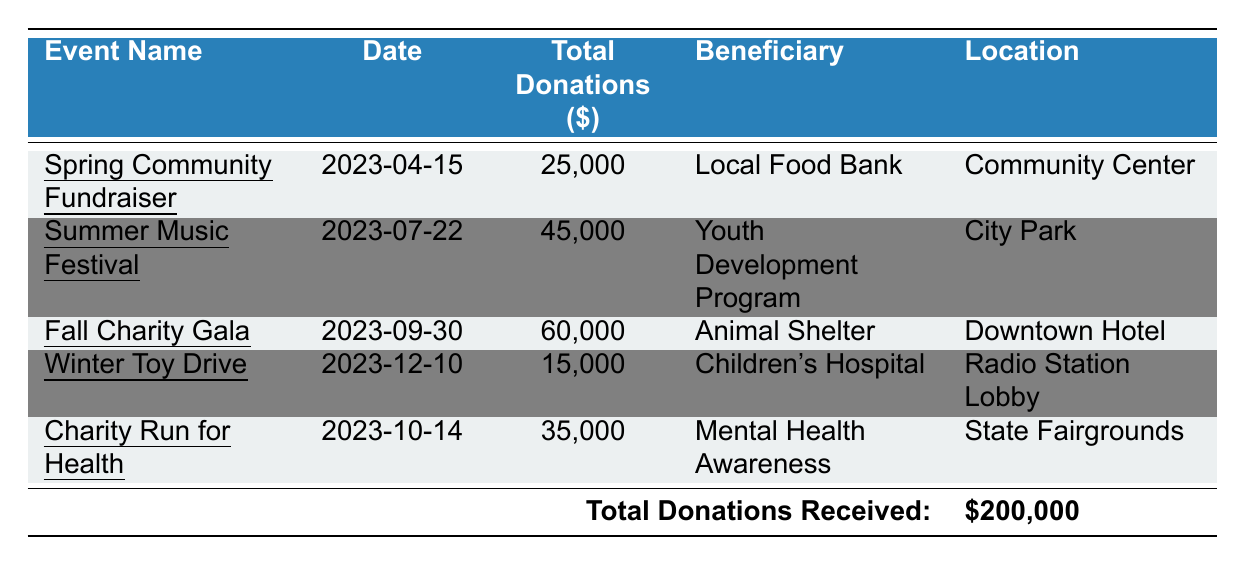What is the total amount of donations received from the Spring Community Fundraiser? The table shows that the total donations for the Spring Community Fundraiser is listed as 25,000.
Answer: 25,000 Which charity benefited from the Fall Charity Gala? According to the table, the beneficiary of the Fall Charity Gala is the Animal Shelter.
Answer: Animal Shelter What is the date of the Summer Music Festival? The table specifies that the Summer Music Festival took place on July 22, 2023.
Answer: July 22, 2023 How much total donation was received from the Winter Toy Drive? The table indicates that the total donations received from the Winter Toy Drive are 15,000.
Answer: 15,000 What is the average donation per event? First, sum the total donations: 25,000 + 45,000 + 60,000 + 15,000 + 35,000 = 180,000. Then, divide by the number of events (5): 180,000 / 5 = 36,000.
Answer: 36,000 Which event generated the highest total donations, and what was that amount? The data indicates that the Fall Charity Gala had the highest total donations of 60,000.
Answer: Fall Charity Gala; 60,000 Was the total amount of donations received in 2023 more than 150,000? The total donations received, which is 200,000, exceeds 150,000, therefore the answer is yes.
Answer: Yes What is the total donation amount received from events held in July and October? The total donations for the Summer Music Festival in July is 45,000, and for the Charity Run for Health in October it is 35,000. Therefore, the total is 45,000 + 35,000 = 80,000.
Answer: 80,000 How much less was the total donation from the Winter Toy Drive compared to the Fall Charity Gala? The Fall Charity Gala received 60,000 and the Winter Toy Drive received 15,000. The difference is 60,000 - 15,000 = 45,000.
Answer: 45,000 What percentage of the total donations received in 2023 were from the Summer Music Festival? To find the percentage, divide the donations from the Summer Music Festival (45,000) by the total donations (200,000) and multiply by 100: (45,000 / 200,000) * 100 = 22.5%.
Answer: 22.5% 